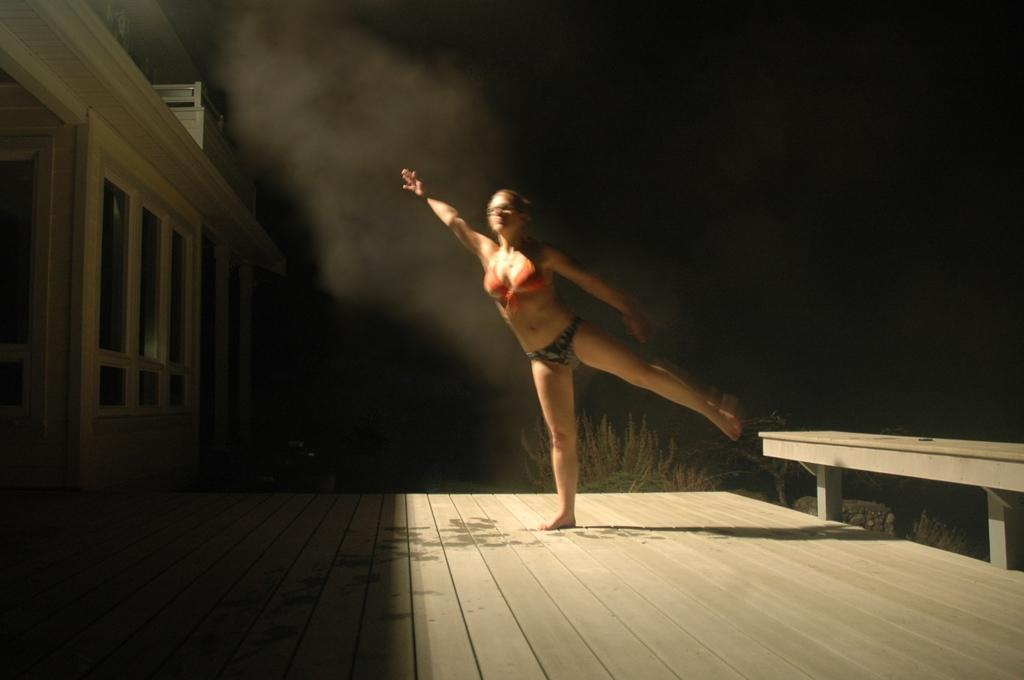What is the main subject of the image? The main subject of the image is a woman standing. What structure is located on the left side of the image? There is a house on the left side of the image. What can be observed about the background of the image? The background of the image is dark. Can you tell me how many kitties are sitting on the woman's shoulder in the image? There are no kitties present in the image. What belief system does the woman in the image follow? There is no information about the woman's belief system in the image. 